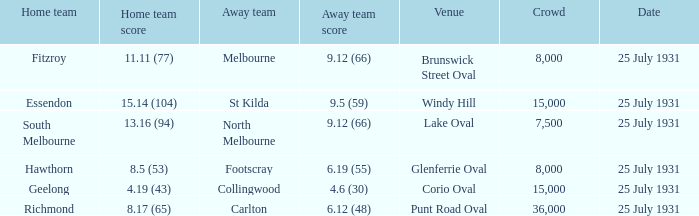When fitzroy was the home team, what did the opposing team score? 9.12 (66). 